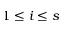<formula> <loc_0><loc_0><loc_500><loc_500>1 \leq i \leq s</formula> 